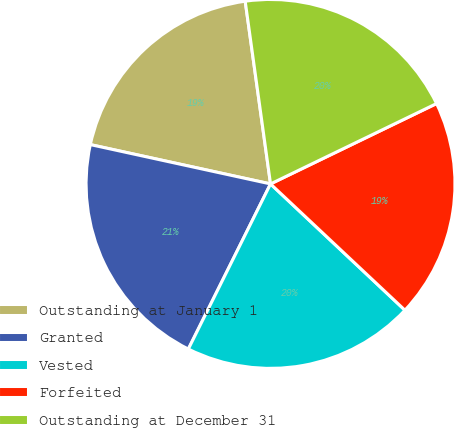<chart> <loc_0><loc_0><loc_500><loc_500><pie_chart><fcel>Outstanding at January 1<fcel>Granted<fcel>Vested<fcel>Forfeited<fcel>Outstanding at December 31<nl><fcel>19.39%<fcel>21.07%<fcel>20.35%<fcel>19.18%<fcel>20.02%<nl></chart> 